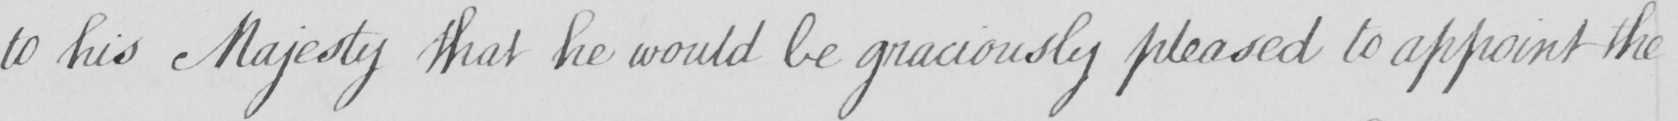Can you tell me what this handwritten text says? to his Majesty that he would be graciously pleased to appoint the 